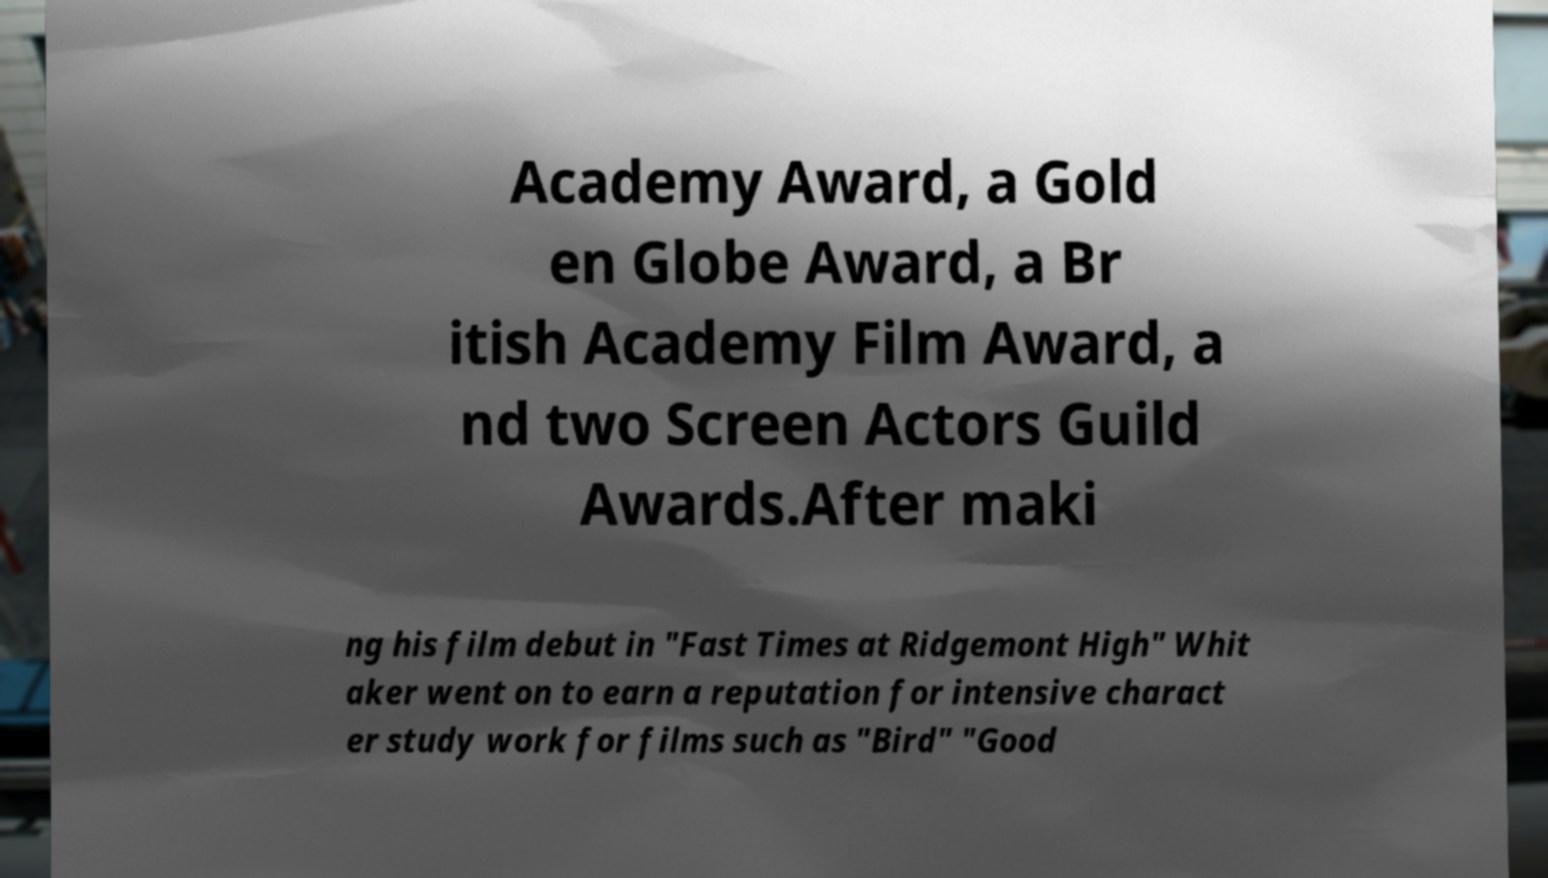There's text embedded in this image that I need extracted. Can you transcribe it verbatim? Academy Award, a Gold en Globe Award, a Br itish Academy Film Award, a nd two Screen Actors Guild Awards.After maki ng his film debut in "Fast Times at Ridgemont High" Whit aker went on to earn a reputation for intensive charact er study work for films such as "Bird" "Good 